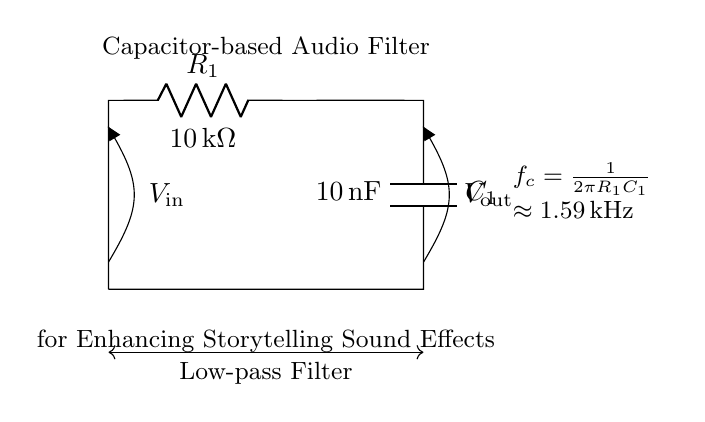What type of filter is this circuit? The circuit is a low-pass filter, as indicated by the label describing the function of the circuit. A low-pass filter allows signals with a frequency lower than a certain cutoff frequency to pass through while attenuating frequencies higher than that threshold.
Answer: Low-pass filter What is the resistance value in the circuit? The resistance value is specified directly next to the resistor component in the diagram. In this case, it is labeled as 10 kilohms.
Answer: 10 kilohms What is the capacitance value in the circuit? The capacitance value can be found next to the capacitor in the circuit diagram. Here, it is labeled as 10 nanofarads.
Answer: 10 nanofarads What is the cutoff frequency of this filter? The cutoff frequency is calculated from the given values of resistance and capacitance using the formula f_c = 1/(2πR_1C_1). Plugging in the values (R_1 = 10 kΩ and C_1 = 10 nF), the result is approximately 1.59 kHz. The corresponding note in the diagram confirms this calculation.
Answer: 1.59 kilohertz How is the output voltage labeled in the circuit? The output voltage is labeled with the symbol V_out, placed at the output node of the circuit diagram. It shows that this is the point from which the output signal can be taken.
Answer: V_out What component determines the filtering behavior in this circuit? The filtering behavior in a resistor-capacitor circuit is mainly determined by the capacitor, which affects how the circuit responds to different frequencies. As the frequency of the input signal increases, the capacitor allows less current to pass through, thus producing a filtering effect.
Answer: Capacitor 